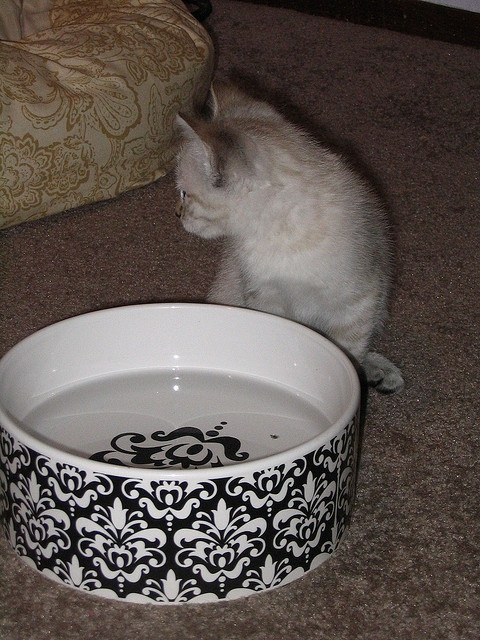Describe the objects in this image and their specific colors. I can see bowl in gray, darkgray, black, and lightgray tones and cat in gray, darkgray, and black tones in this image. 